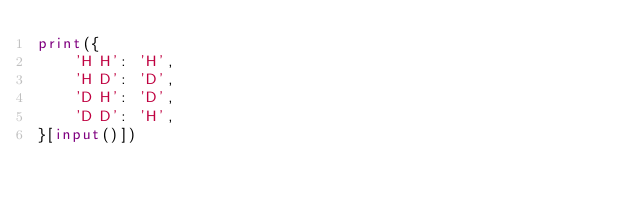Convert code to text. <code><loc_0><loc_0><loc_500><loc_500><_Python_>print({
	'H H': 'H',
  	'H D': 'D',
  	'D H': 'D',
  	'D D': 'H',
}[input()])</code> 